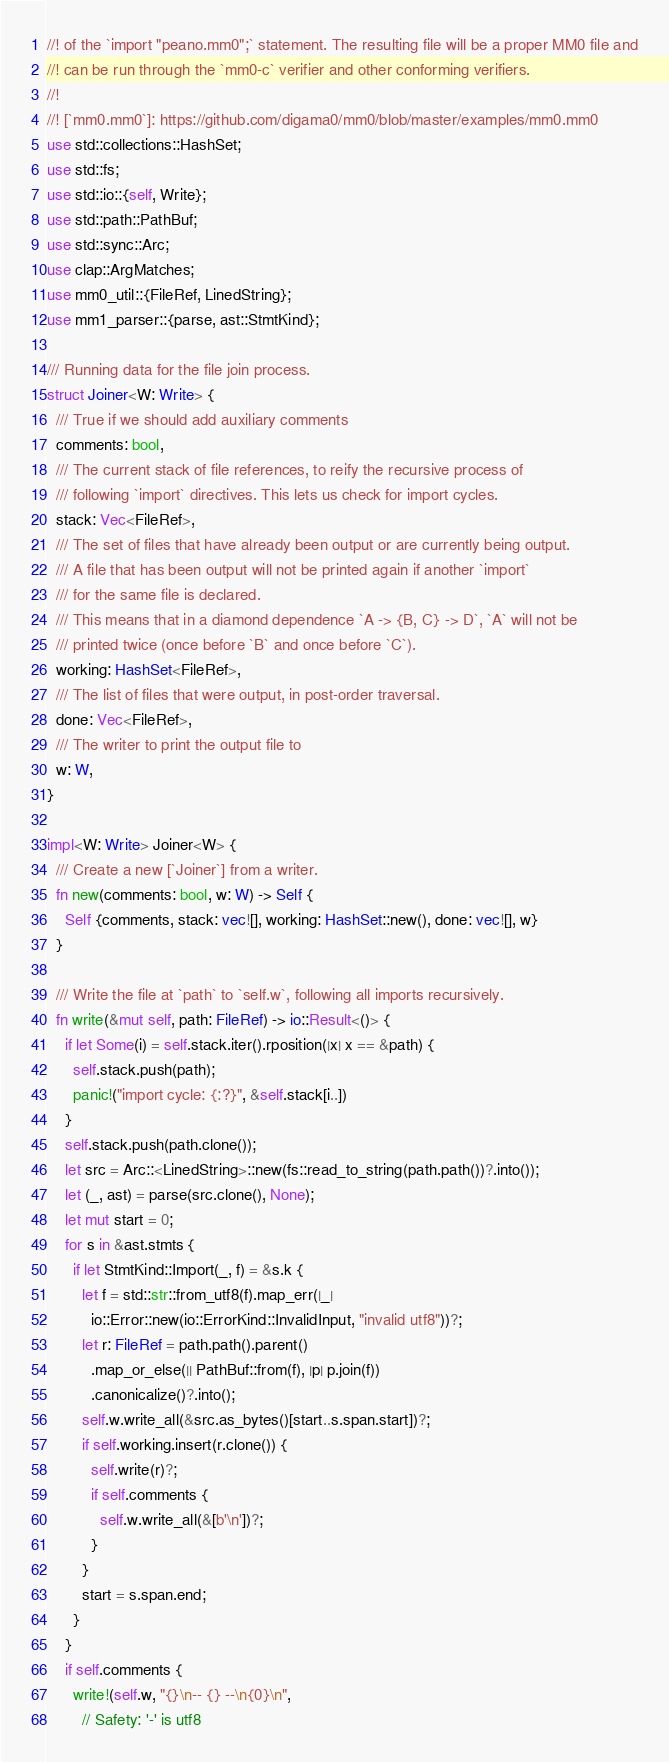Convert code to text. <code><loc_0><loc_0><loc_500><loc_500><_Rust_>//! of the `import "peano.mm0";` statement. The resulting file will be a proper MM0 file and
//! can be run through the `mm0-c` verifier and other conforming verifiers.
//!
//! [`mm0.mm0`]: https://github.com/digama0/mm0/blob/master/examples/mm0.mm0
use std::collections::HashSet;
use std::fs;
use std::io::{self, Write};
use std::path::PathBuf;
use std::sync::Arc;
use clap::ArgMatches;
use mm0_util::{FileRef, LinedString};
use mm1_parser::{parse, ast::StmtKind};

/// Running data for the file join process.
struct Joiner<W: Write> {
  /// True if we should add auxiliary comments
  comments: bool,
  /// The current stack of file references, to reify the recursive process of
  /// following `import` directives. This lets us check for import cycles.
  stack: Vec<FileRef>,
  /// The set of files that have already been output or are currently being output.
  /// A file that has been output will not be printed again if another `import`
  /// for the same file is declared.
  /// This means that in a diamond dependence `A -> {B, C} -> D`, `A` will not be
  /// printed twice (once before `B` and once before `C`).
  working: HashSet<FileRef>,
  /// The list of files that were output, in post-order traversal.
  done: Vec<FileRef>,
  /// The writer to print the output file to
  w: W,
}

impl<W: Write> Joiner<W> {
  /// Create a new [`Joiner`] from a writer.
  fn new(comments: bool, w: W) -> Self {
    Self {comments, stack: vec![], working: HashSet::new(), done: vec![], w}
  }

  /// Write the file at `path` to `self.w`, following all imports recursively.
  fn write(&mut self, path: FileRef) -> io::Result<()> {
    if let Some(i) = self.stack.iter().rposition(|x| x == &path) {
      self.stack.push(path);
      panic!("import cycle: {:?}", &self.stack[i..])
    }
    self.stack.push(path.clone());
    let src = Arc::<LinedString>::new(fs::read_to_string(path.path())?.into());
    let (_, ast) = parse(src.clone(), None);
    let mut start = 0;
    for s in &ast.stmts {
      if let StmtKind::Import(_, f) = &s.k {
        let f = std::str::from_utf8(f).map_err(|_|
          io::Error::new(io::ErrorKind::InvalidInput, "invalid utf8"))?;
        let r: FileRef = path.path().parent()
          .map_or_else(|| PathBuf::from(f), |p| p.join(f))
          .canonicalize()?.into();
        self.w.write_all(&src.as_bytes()[start..s.span.start])?;
        if self.working.insert(r.clone()) {
          self.write(r)?;
          if self.comments {
            self.w.write_all(&[b'\n'])?;
          }
        }
        start = s.span.end;
      }
    }
    if self.comments {
      write!(self.w, "{}\n-- {} --\n{0}\n",
        // Safety: '-' is utf8</code> 